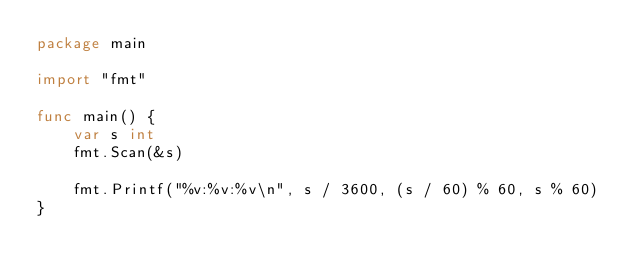Convert code to text. <code><loc_0><loc_0><loc_500><loc_500><_Go_>package main

import "fmt"

func main() {
    var s int
    fmt.Scan(&s)

    fmt.Printf("%v:%v:%v\n", s / 3600, (s / 60) % 60, s % 60)
}
</code> 